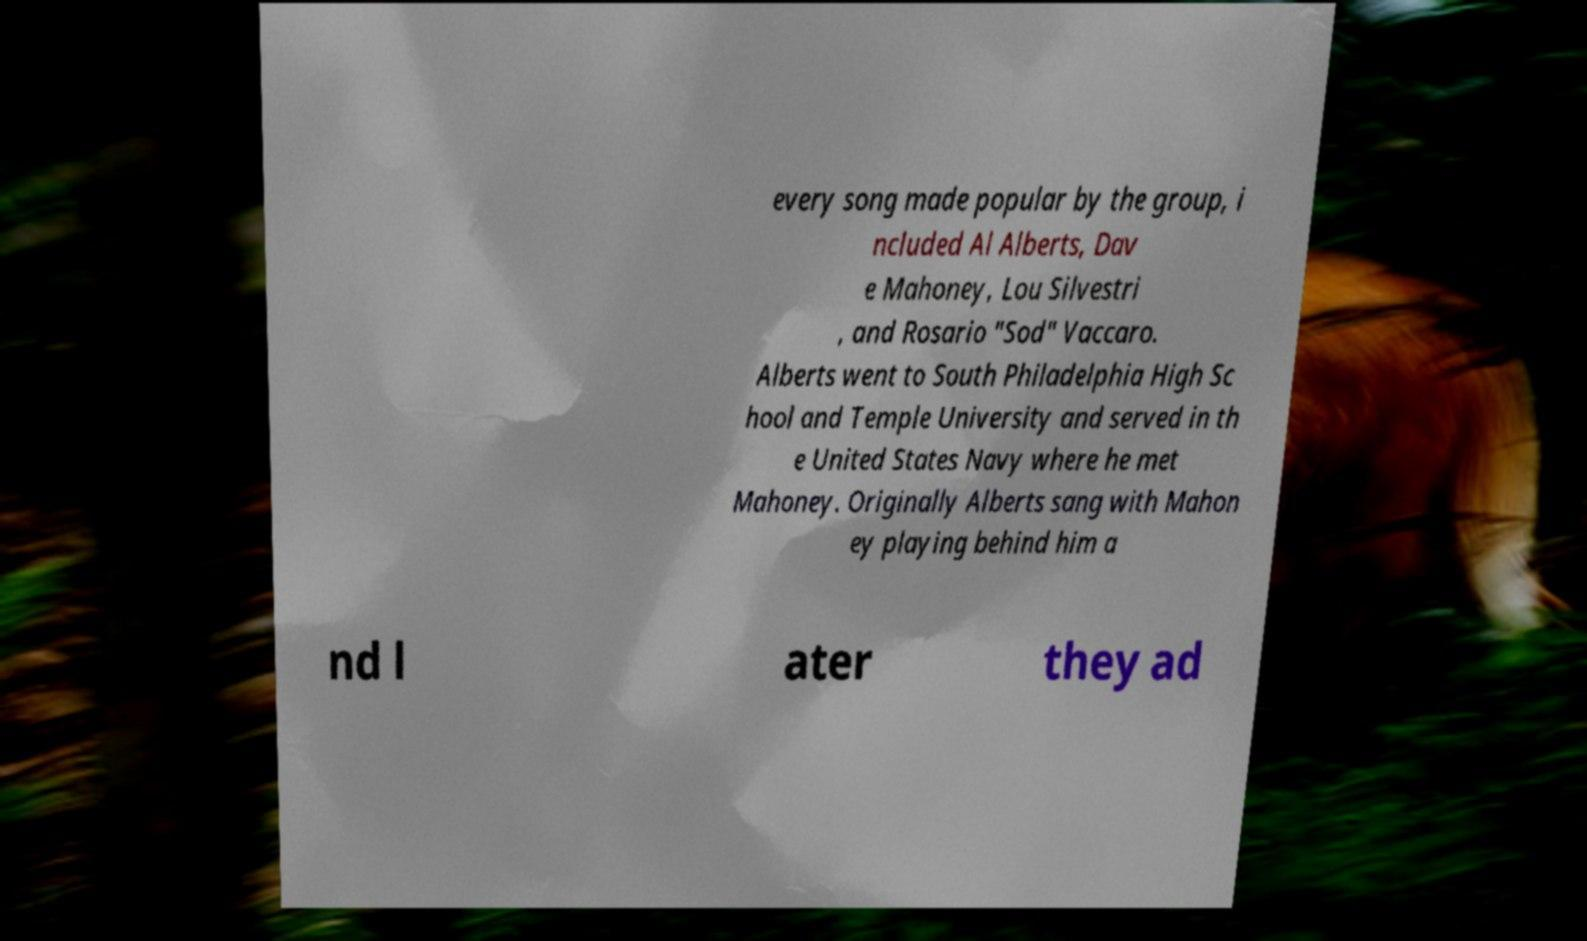Please identify and transcribe the text found in this image. every song made popular by the group, i ncluded Al Alberts, Dav e Mahoney, Lou Silvestri , and Rosario "Sod" Vaccaro. Alberts went to South Philadelphia High Sc hool and Temple University and served in th e United States Navy where he met Mahoney. Originally Alberts sang with Mahon ey playing behind him a nd l ater they ad 